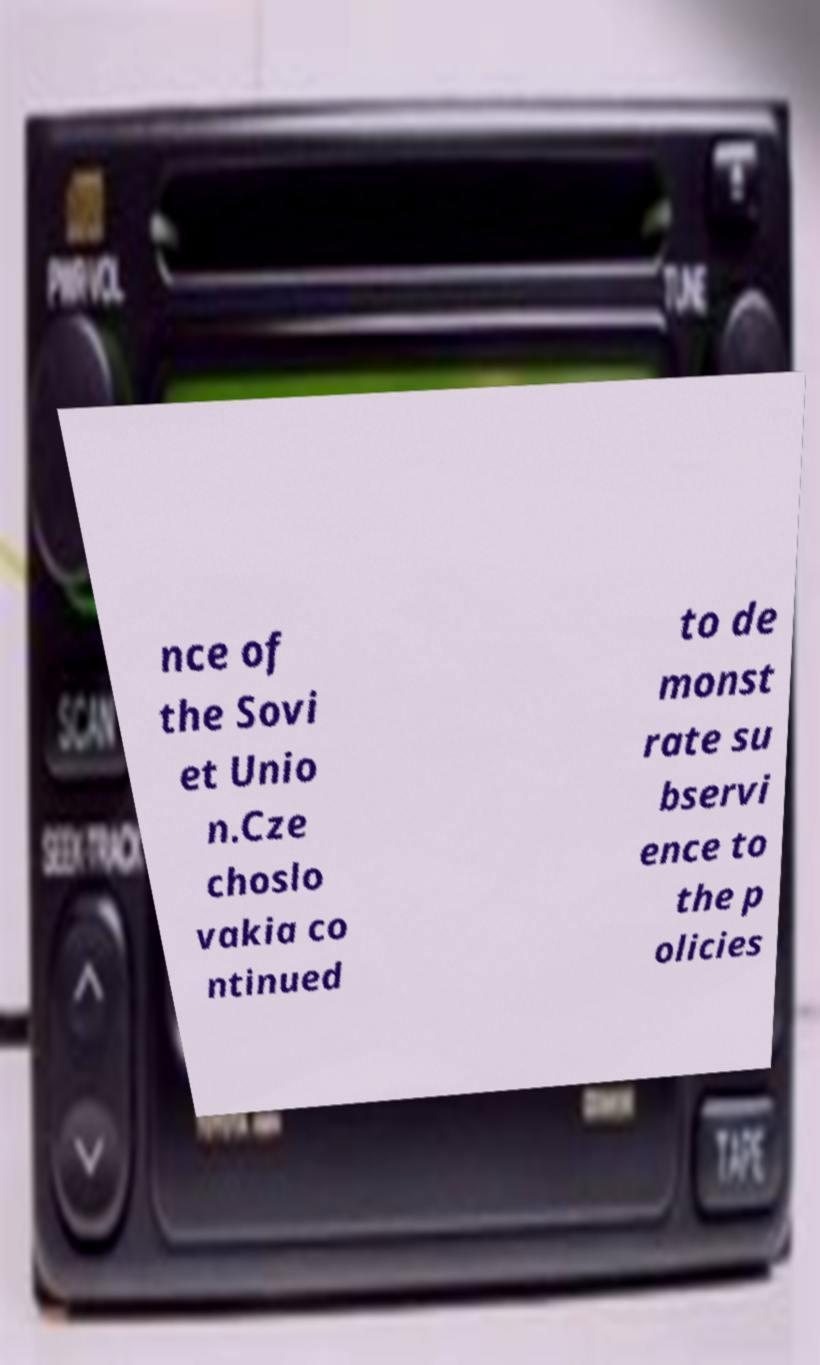What messages or text are displayed in this image? I need them in a readable, typed format. nce of the Sovi et Unio n.Cze choslo vakia co ntinued to de monst rate su bservi ence to the p olicies 